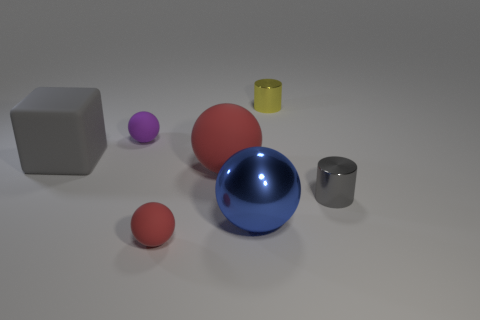Add 3 gray balls. How many objects exist? 10 Subtract all balls. How many objects are left? 3 Subtract all large blue things. Subtract all big metallic spheres. How many objects are left? 5 Add 5 yellow cylinders. How many yellow cylinders are left? 6 Add 1 metallic blocks. How many metallic blocks exist? 1 Subtract 1 purple balls. How many objects are left? 6 